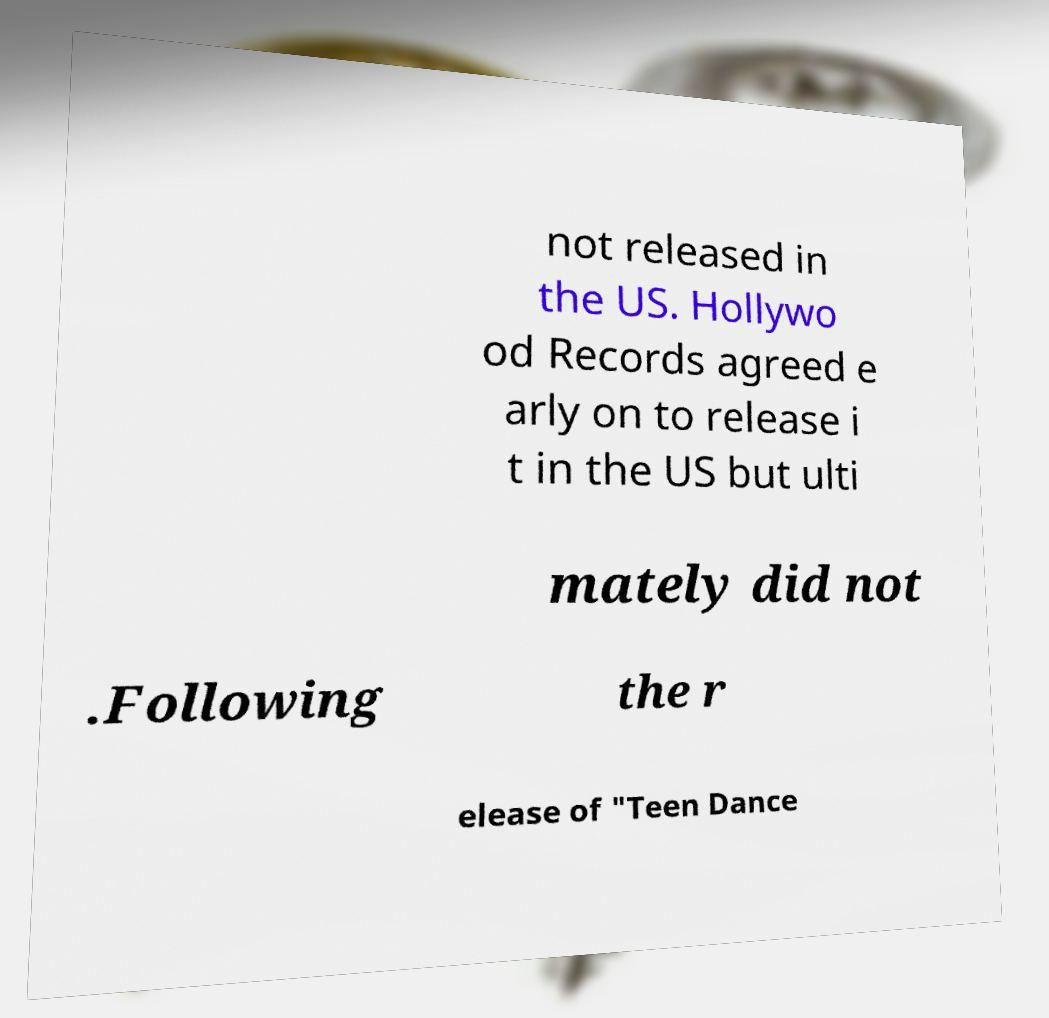Please identify and transcribe the text found in this image. not released in the US. Hollywo od Records agreed e arly on to release i t in the US but ulti mately did not .Following the r elease of "Teen Dance 